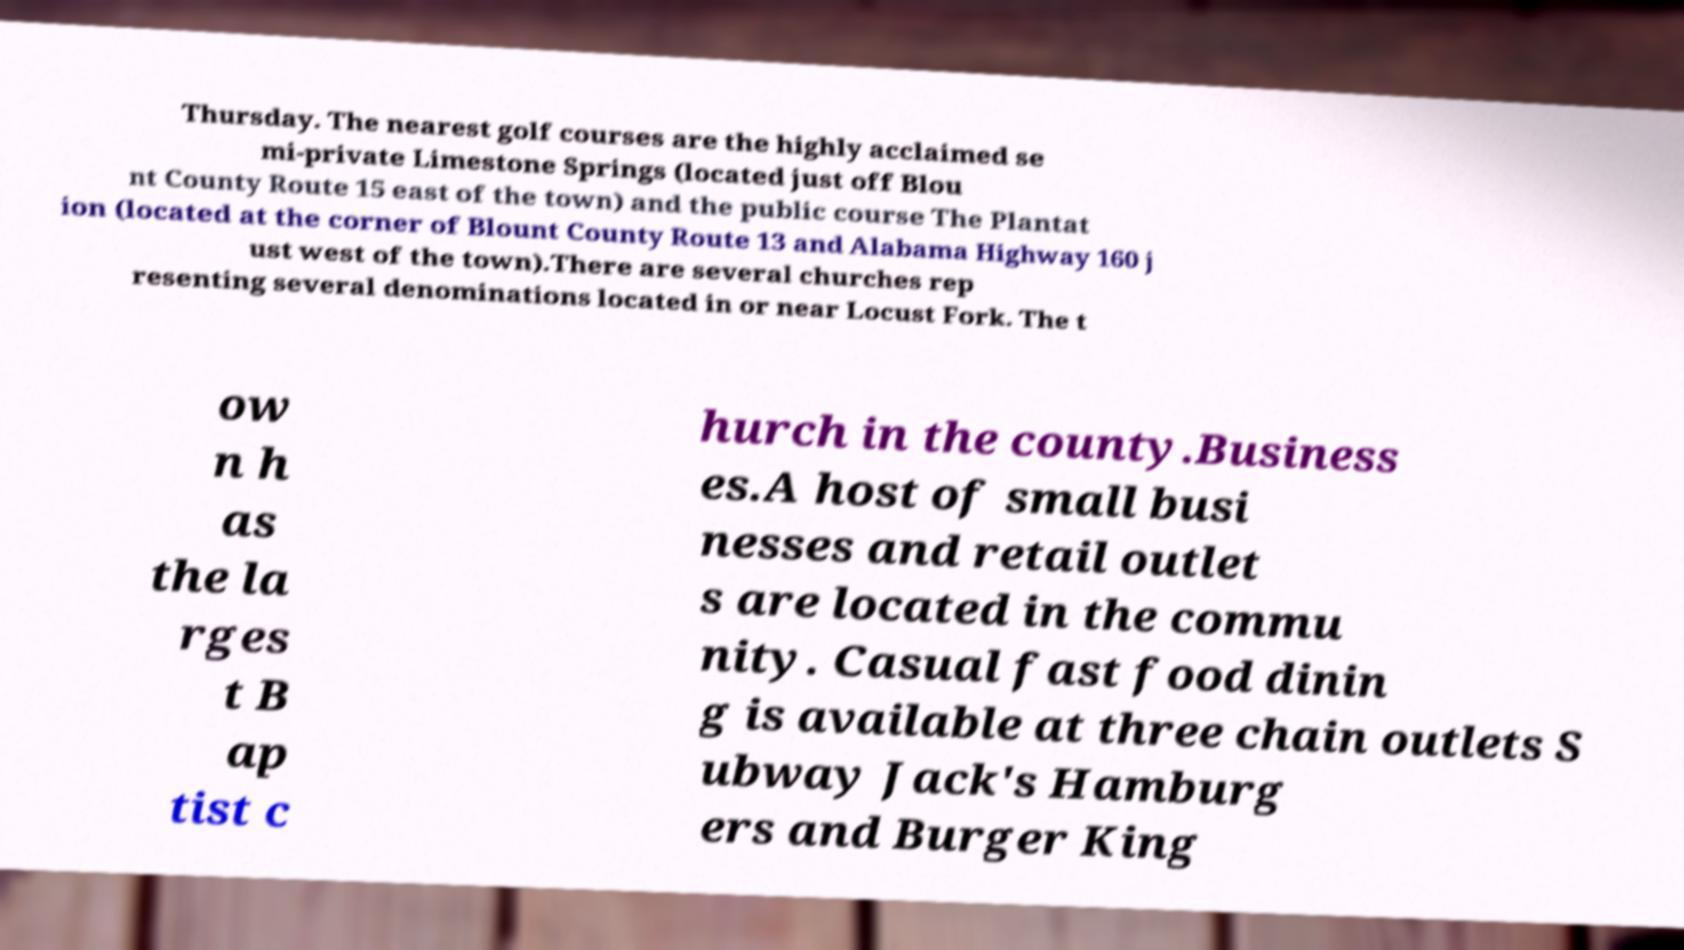What messages or text are displayed in this image? I need them in a readable, typed format. Thursday. The nearest golf courses are the highly acclaimed se mi-private Limestone Springs (located just off Blou nt County Route 15 east of the town) and the public course The Plantat ion (located at the corner of Blount County Route 13 and Alabama Highway 160 j ust west of the town).There are several churches rep resenting several denominations located in or near Locust Fork. The t ow n h as the la rges t B ap tist c hurch in the county.Business es.A host of small busi nesses and retail outlet s are located in the commu nity. Casual fast food dinin g is available at three chain outlets S ubway Jack's Hamburg ers and Burger King 